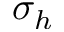Convert formula to latex. <formula><loc_0><loc_0><loc_500><loc_500>\sigma _ { h }</formula> 